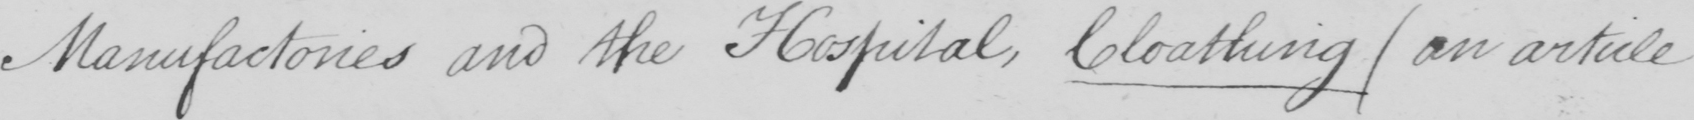Please provide the text content of this handwritten line. Manufactories and the Hospital , Cloathing  ( an article 